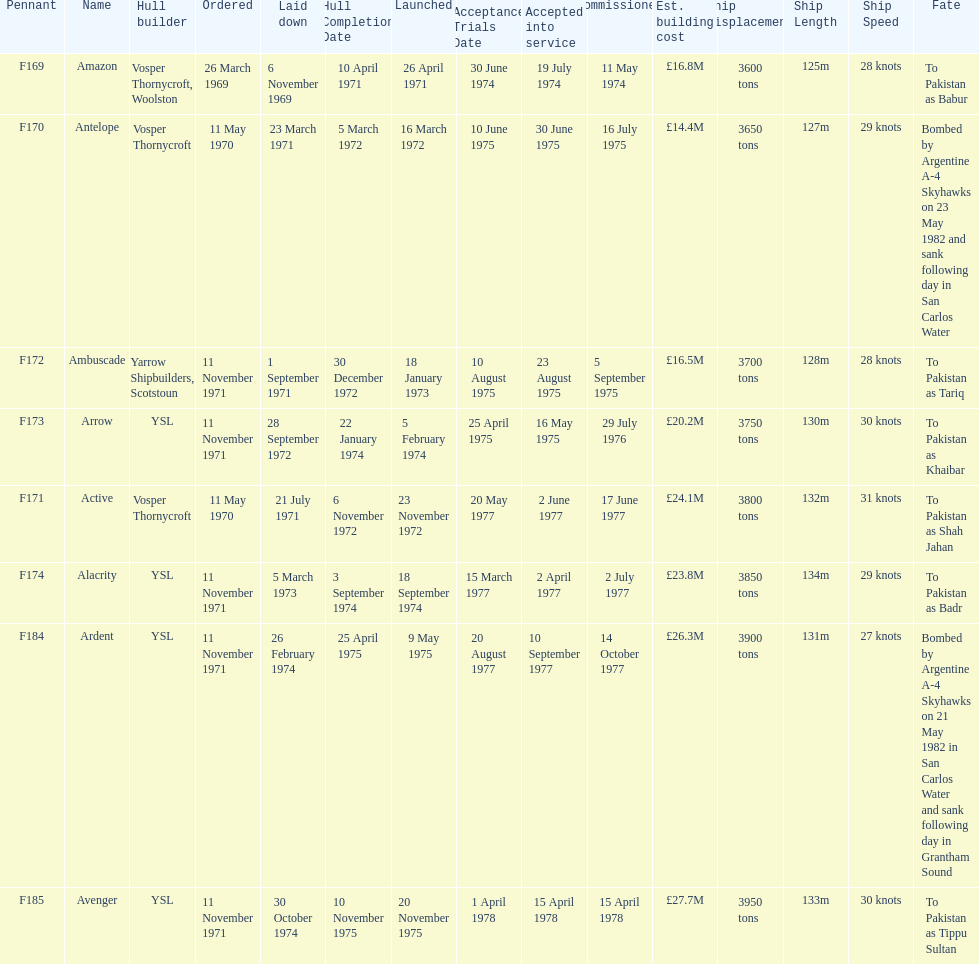What is the name of the ship listed after ardent? Avenger. 